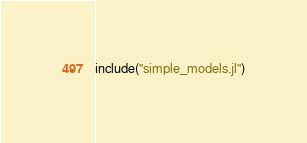Convert code to text. <code><loc_0><loc_0><loc_500><loc_500><_Julia_>
include("simple_models.jl")
</code> 